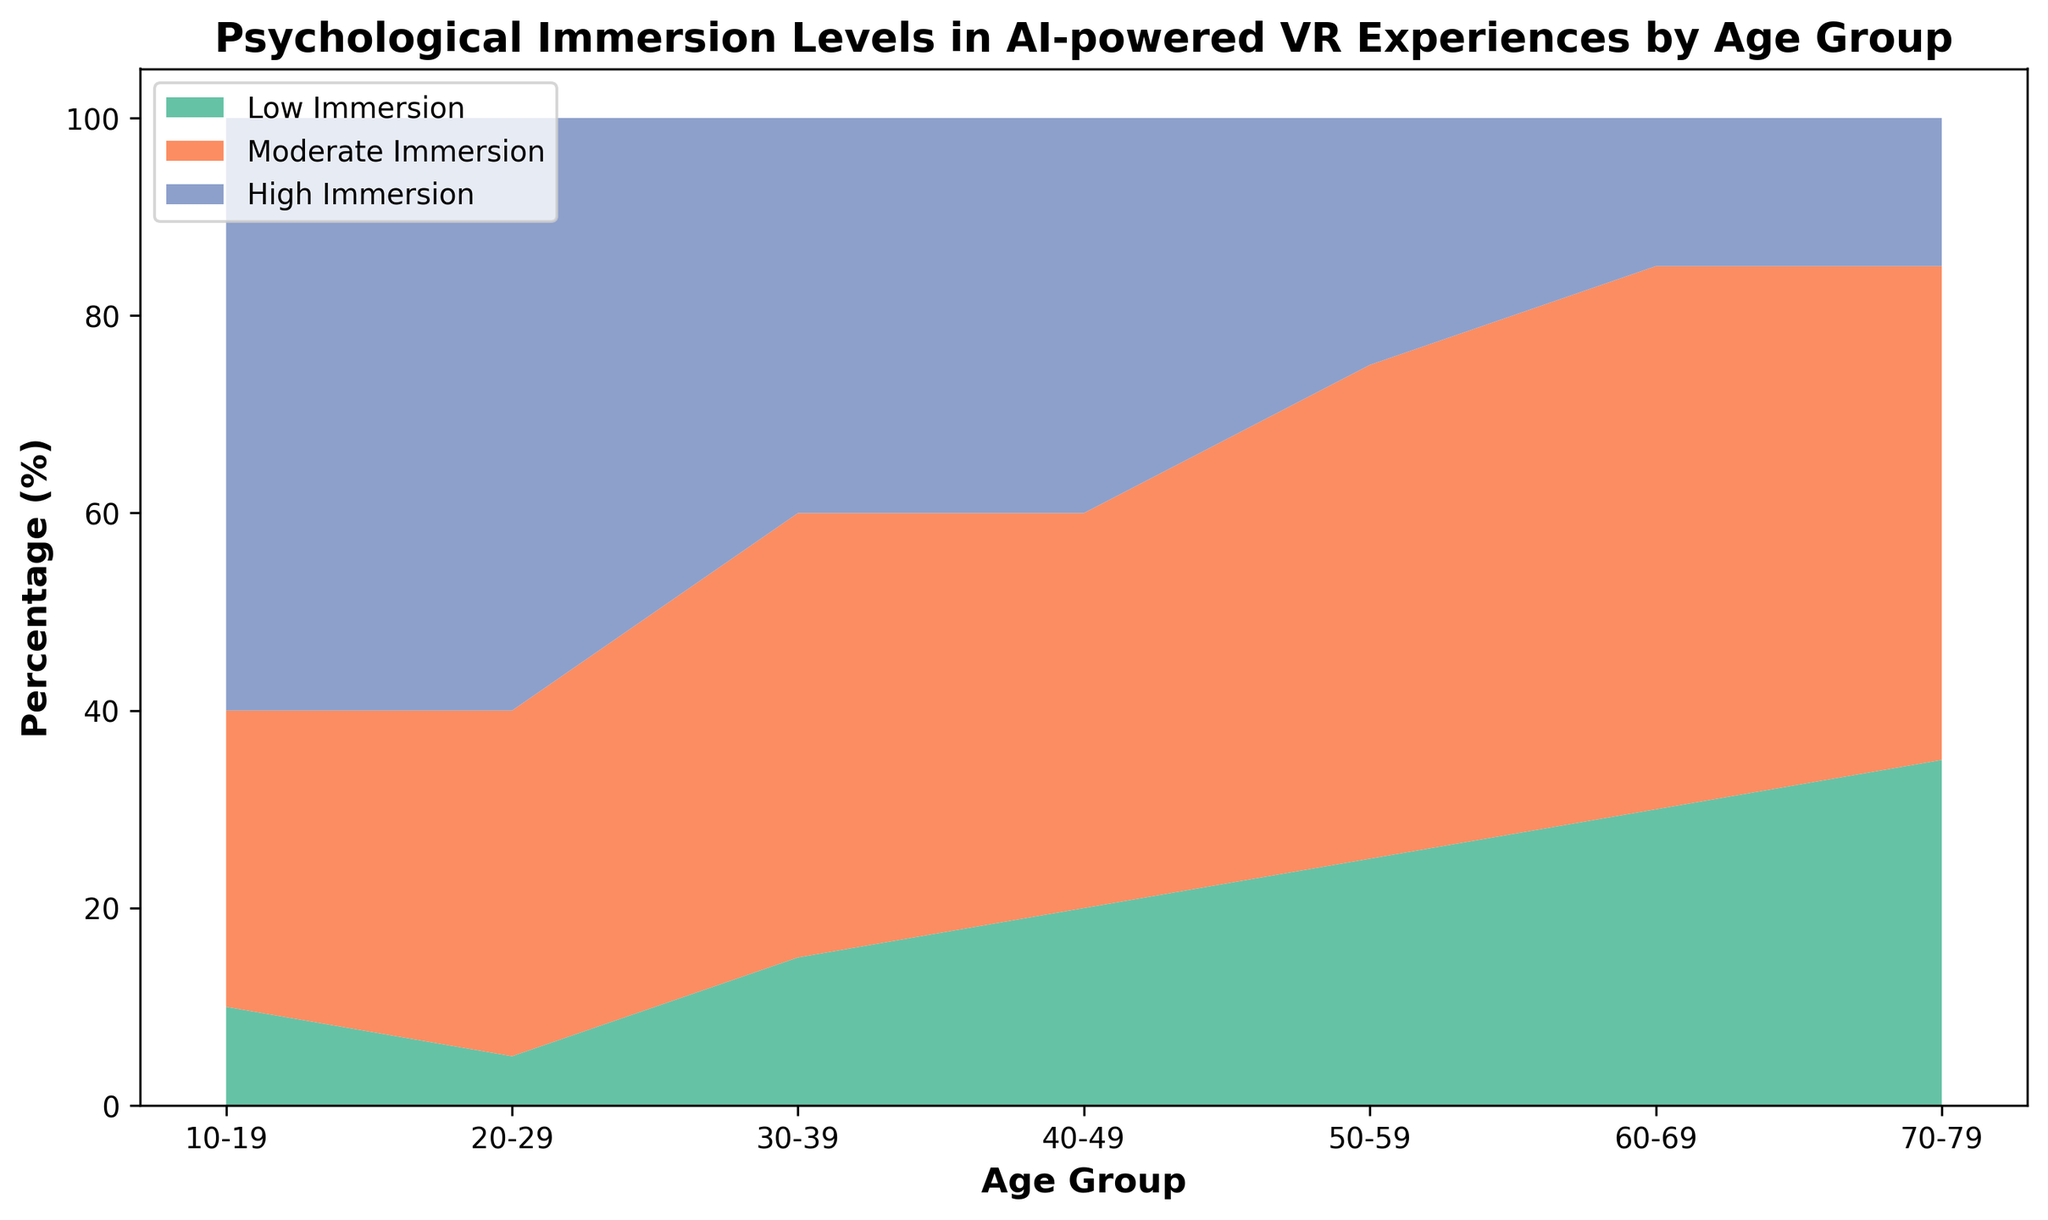Which age group has the highest percentage of Low Immersion? The highest point of the greenish segment of the chart represents Low Immersion. By examining the height of this segment, we notice that the age group 70-79 has the highest proportion of Low Immersion, peaking at 35%.
Answer: 70-79 Which age group has an equal percentage of High Immersion and Moderate Immersion? By observing the intersection between the top two segments of the chart, we see that the ages 30-39 and 40-49 both have equal heights for High Immersion (the highest segment) and Moderate Immersion (the middle segment). Both are at 40%.
Answer: 30-39, 40-49 What is the sum of Low Immersion percentages for the age groups 50-59 and 60-69? We sum the Low Immersion percentages for these age groups by adding their heights in the age segments: 25% for 50-59 and 30% for 60-69. The total is 25% + 30% = 55%.
Answer: 55% What is the range of percentages for High Immersion across all age groups? The range is calculated by subtracting the smallest value from the largest value for High Immersion. The highest is 60% (occurs in 10-19 and 20-29), and the lowest is 15% (occurs in 60-69 and 70-79). So, the range is 60% - 15% = 45%.
Answer: 45% Which age group has the lowest percentage of High Immersion? By observing the height of the topmost segment, which represents High Immersion, we notice that the lowest points at 15% occur for age groups 60-69 and 70-79.
Answer: 60-69, 70-79 For the age group 20-29, how does the percentage of High Immersion compare to Low Immersion? By examining the heights for this age group, we see High Immersion is at 60% and Low Immersion is at 5%. Therefore, the High Immersion is significantly higher.
Answer: Higher What is the difference in the percentage of Moderate Immersion between age groups 10-19 and 50-59? We find the percentages for Moderate Immersion for both age groups (30% for 10-19 and 50% for 50-59) and then subtract the smaller from the larger: 50% - 30% = 20%.
Answer: 20% What percentage constitutes Moderate Immersion for the age group 60-69? By reviewing the middle segment’s height for this age group, we note that Moderate Immersion is 55%.
Answer: 55% In which age group is Low Immersion the smallest fraction of overall immersion levels? By checking the smallest height represented by Low Immersion (the greenish segment) for each age group, it is smallest for ages 20-29 at 5%.
Answer: 20-29 